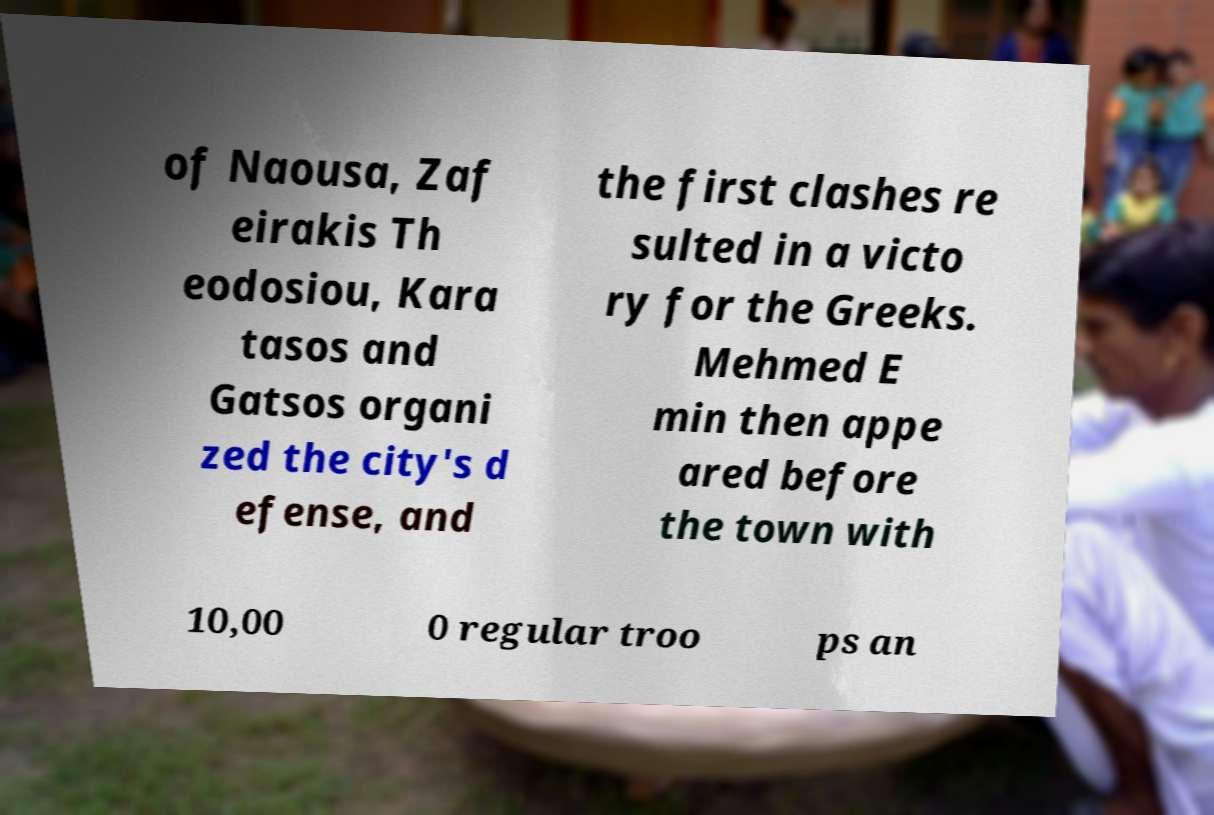For documentation purposes, I need the text within this image transcribed. Could you provide that? of Naousa, Zaf eirakis Th eodosiou, Kara tasos and Gatsos organi zed the city's d efense, and the first clashes re sulted in a victo ry for the Greeks. Mehmed E min then appe ared before the town with 10,00 0 regular troo ps an 